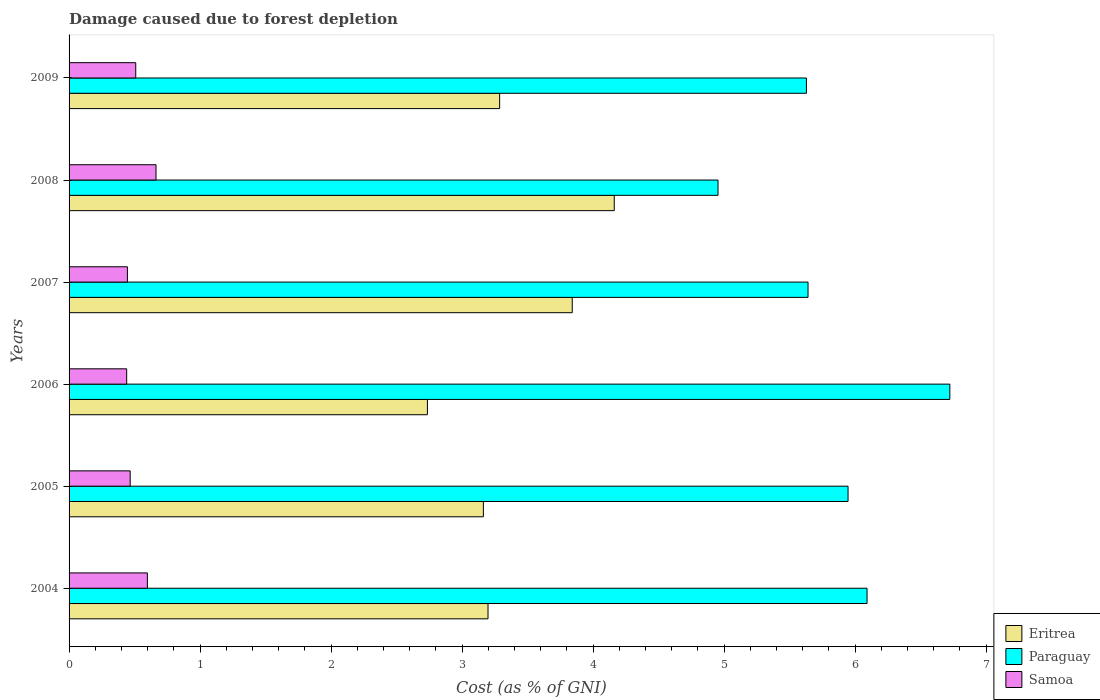How many groups of bars are there?
Provide a short and direct response. 6. Are the number of bars per tick equal to the number of legend labels?
Provide a short and direct response. Yes. What is the label of the 3rd group of bars from the top?
Offer a terse response. 2007. What is the cost of damage caused due to forest depletion in Samoa in 2004?
Provide a succinct answer. 0.6. Across all years, what is the maximum cost of damage caused due to forest depletion in Eritrea?
Make the answer very short. 4.16. Across all years, what is the minimum cost of damage caused due to forest depletion in Paraguay?
Provide a short and direct response. 4.95. What is the total cost of damage caused due to forest depletion in Paraguay in the graph?
Provide a short and direct response. 34.99. What is the difference between the cost of damage caused due to forest depletion in Eritrea in 2006 and that in 2008?
Your answer should be very brief. -1.43. What is the difference between the cost of damage caused due to forest depletion in Samoa in 2006 and the cost of damage caused due to forest depletion in Eritrea in 2007?
Offer a terse response. -3.4. What is the average cost of damage caused due to forest depletion in Paraguay per year?
Give a very brief answer. 5.83. In the year 2009, what is the difference between the cost of damage caused due to forest depletion in Eritrea and cost of damage caused due to forest depletion in Paraguay?
Your answer should be compact. -2.34. What is the ratio of the cost of damage caused due to forest depletion in Samoa in 2004 to that in 2008?
Offer a very short reply. 0.9. Is the difference between the cost of damage caused due to forest depletion in Eritrea in 2005 and 2006 greater than the difference between the cost of damage caused due to forest depletion in Paraguay in 2005 and 2006?
Provide a succinct answer. Yes. What is the difference between the highest and the second highest cost of damage caused due to forest depletion in Samoa?
Offer a terse response. 0.07. What is the difference between the highest and the lowest cost of damage caused due to forest depletion in Eritrea?
Make the answer very short. 1.43. In how many years, is the cost of damage caused due to forest depletion in Samoa greater than the average cost of damage caused due to forest depletion in Samoa taken over all years?
Provide a succinct answer. 2. Is the sum of the cost of damage caused due to forest depletion in Eritrea in 2004 and 2006 greater than the maximum cost of damage caused due to forest depletion in Samoa across all years?
Provide a succinct answer. Yes. What does the 3rd bar from the top in 2004 represents?
Provide a short and direct response. Eritrea. What does the 1st bar from the bottom in 2007 represents?
Your response must be concise. Eritrea. Is it the case that in every year, the sum of the cost of damage caused due to forest depletion in Samoa and cost of damage caused due to forest depletion in Paraguay is greater than the cost of damage caused due to forest depletion in Eritrea?
Make the answer very short. Yes. Are all the bars in the graph horizontal?
Your answer should be compact. Yes. What is the difference between two consecutive major ticks on the X-axis?
Provide a short and direct response. 1. Where does the legend appear in the graph?
Provide a succinct answer. Bottom right. How many legend labels are there?
Keep it short and to the point. 3. How are the legend labels stacked?
Provide a succinct answer. Vertical. What is the title of the graph?
Offer a very short reply. Damage caused due to forest depletion. What is the label or title of the X-axis?
Offer a terse response. Cost (as % of GNI). What is the Cost (as % of GNI) in Eritrea in 2004?
Offer a very short reply. 3.2. What is the Cost (as % of GNI) in Paraguay in 2004?
Provide a succinct answer. 6.09. What is the Cost (as % of GNI) of Samoa in 2004?
Provide a succinct answer. 0.6. What is the Cost (as % of GNI) of Eritrea in 2005?
Your response must be concise. 3.16. What is the Cost (as % of GNI) of Paraguay in 2005?
Provide a short and direct response. 5.95. What is the Cost (as % of GNI) in Samoa in 2005?
Your answer should be compact. 0.47. What is the Cost (as % of GNI) of Eritrea in 2006?
Offer a terse response. 2.74. What is the Cost (as % of GNI) of Paraguay in 2006?
Offer a very short reply. 6.72. What is the Cost (as % of GNI) of Samoa in 2006?
Your answer should be very brief. 0.44. What is the Cost (as % of GNI) in Eritrea in 2007?
Provide a succinct answer. 3.84. What is the Cost (as % of GNI) in Paraguay in 2007?
Offer a terse response. 5.64. What is the Cost (as % of GNI) of Samoa in 2007?
Ensure brevity in your answer.  0.45. What is the Cost (as % of GNI) of Eritrea in 2008?
Provide a succinct answer. 4.16. What is the Cost (as % of GNI) in Paraguay in 2008?
Make the answer very short. 4.95. What is the Cost (as % of GNI) in Samoa in 2008?
Your answer should be very brief. 0.66. What is the Cost (as % of GNI) in Eritrea in 2009?
Your answer should be very brief. 3.29. What is the Cost (as % of GNI) of Paraguay in 2009?
Make the answer very short. 5.63. What is the Cost (as % of GNI) in Samoa in 2009?
Provide a succinct answer. 0.51. Across all years, what is the maximum Cost (as % of GNI) in Eritrea?
Your answer should be very brief. 4.16. Across all years, what is the maximum Cost (as % of GNI) of Paraguay?
Ensure brevity in your answer.  6.72. Across all years, what is the maximum Cost (as % of GNI) in Samoa?
Provide a succinct answer. 0.66. Across all years, what is the minimum Cost (as % of GNI) in Eritrea?
Offer a terse response. 2.74. Across all years, what is the minimum Cost (as % of GNI) in Paraguay?
Provide a succinct answer. 4.95. Across all years, what is the minimum Cost (as % of GNI) of Samoa?
Give a very brief answer. 0.44. What is the total Cost (as % of GNI) in Eritrea in the graph?
Keep it short and to the point. 20.39. What is the total Cost (as % of GNI) in Paraguay in the graph?
Provide a short and direct response. 34.99. What is the total Cost (as % of GNI) of Samoa in the graph?
Provide a succinct answer. 3.12. What is the difference between the Cost (as % of GNI) of Eritrea in 2004 and that in 2005?
Give a very brief answer. 0.04. What is the difference between the Cost (as % of GNI) of Paraguay in 2004 and that in 2005?
Make the answer very short. 0.15. What is the difference between the Cost (as % of GNI) of Samoa in 2004 and that in 2005?
Ensure brevity in your answer.  0.13. What is the difference between the Cost (as % of GNI) in Eritrea in 2004 and that in 2006?
Your answer should be very brief. 0.46. What is the difference between the Cost (as % of GNI) of Paraguay in 2004 and that in 2006?
Your response must be concise. -0.63. What is the difference between the Cost (as % of GNI) in Samoa in 2004 and that in 2006?
Provide a short and direct response. 0.16. What is the difference between the Cost (as % of GNI) in Eritrea in 2004 and that in 2007?
Offer a very short reply. -0.64. What is the difference between the Cost (as % of GNI) of Paraguay in 2004 and that in 2007?
Your answer should be compact. 0.45. What is the difference between the Cost (as % of GNI) in Samoa in 2004 and that in 2007?
Offer a very short reply. 0.15. What is the difference between the Cost (as % of GNI) of Eritrea in 2004 and that in 2008?
Ensure brevity in your answer.  -0.96. What is the difference between the Cost (as % of GNI) in Paraguay in 2004 and that in 2008?
Your response must be concise. 1.14. What is the difference between the Cost (as % of GNI) of Samoa in 2004 and that in 2008?
Keep it short and to the point. -0.07. What is the difference between the Cost (as % of GNI) of Eritrea in 2004 and that in 2009?
Offer a very short reply. -0.09. What is the difference between the Cost (as % of GNI) in Paraguay in 2004 and that in 2009?
Provide a succinct answer. 0.46. What is the difference between the Cost (as % of GNI) of Samoa in 2004 and that in 2009?
Ensure brevity in your answer.  0.09. What is the difference between the Cost (as % of GNI) of Eritrea in 2005 and that in 2006?
Your answer should be compact. 0.43. What is the difference between the Cost (as % of GNI) in Paraguay in 2005 and that in 2006?
Offer a very short reply. -0.78. What is the difference between the Cost (as % of GNI) of Samoa in 2005 and that in 2006?
Your answer should be compact. 0.03. What is the difference between the Cost (as % of GNI) of Eritrea in 2005 and that in 2007?
Your answer should be very brief. -0.68. What is the difference between the Cost (as % of GNI) of Paraguay in 2005 and that in 2007?
Your response must be concise. 0.31. What is the difference between the Cost (as % of GNI) of Samoa in 2005 and that in 2007?
Your response must be concise. 0.02. What is the difference between the Cost (as % of GNI) of Eritrea in 2005 and that in 2008?
Offer a terse response. -1. What is the difference between the Cost (as % of GNI) in Paraguay in 2005 and that in 2008?
Provide a succinct answer. 0.99. What is the difference between the Cost (as % of GNI) in Samoa in 2005 and that in 2008?
Offer a terse response. -0.2. What is the difference between the Cost (as % of GNI) in Eritrea in 2005 and that in 2009?
Ensure brevity in your answer.  -0.12. What is the difference between the Cost (as % of GNI) in Paraguay in 2005 and that in 2009?
Ensure brevity in your answer.  0.32. What is the difference between the Cost (as % of GNI) of Samoa in 2005 and that in 2009?
Your response must be concise. -0.04. What is the difference between the Cost (as % of GNI) of Eritrea in 2006 and that in 2007?
Keep it short and to the point. -1.11. What is the difference between the Cost (as % of GNI) in Paraguay in 2006 and that in 2007?
Your answer should be compact. 1.08. What is the difference between the Cost (as % of GNI) in Samoa in 2006 and that in 2007?
Your response must be concise. -0.01. What is the difference between the Cost (as % of GNI) in Eritrea in 2006 and that in 2008?
Offer a very short reply. -1.43. What is the difference between the Cost (as % of GNI) in Paraguay in 2006 and that in 2008?
Ensure brevity in your answer.  1.77. What is the difference between the Cost (as % of GNI) of Samoa in 2006 and that in 2008?
Your answer should be compact. -0.22. What is the difference between the Cost (as % of GNI) in Eritrea in 2006 and that in 2009?
Provide a short and direct response. -0.55. What is the difference between the Cost (as % of GNI) of Paraguay in 2006 and that in 2009?
Provide a short and direct response. 1.09. What is the difference between the Cost (as % of GNI) in Samoa in 2006 and that in 2009?
Provide a succinct answer. -0.07. What is the difference between the Cost (as % of GNI) of Eritrea in 2007 and that in 2008?
Make the answer very short. -0.32. What is the difference between the Cost (as % of GNI) in Paraguay in 2007 and that in 2008?
Offer a very short reply. 0.69. What is the difference between the Cost (as % of GNI) in Samoa in 2007 and that in 2008?
Ensure brevity in your answer.  -0.22. What is the difference between the Cost (as % of GNI) of Eritrea in 2007 and that in 2009?
Ensure brevity in your answer.  0.55. What is the difference between the Cost (as % of GNI) of Paraguay in 2007 and that in 2009?
Provide a short and direct response. 0.01. What is the difference between the Cost (as % of GNI) in Samoa in 2007 and that in 2009?
Your response must be concise. -0.06. What is the difference between the Cost (as % of GNI) in Eritrea in 2008 and that in 2009?
Keep it short and to the point. 0.87. What is the difference between the Cost (as % of GNI) of Paraguay in 2008 and that in 2009?
Your response must be concise. -0.68. What is the difference between the Cost (as % of GNI) in Samoa in 2008 and that in 2009?
Your response must be concise. 0.15. What is the difference between the Cost (as % of GNI) in Eritrea in 2004 and the Cost (as % of GNI) in Paraguay in 2005?
Make the answer very short. -2.75. What is the difference between the Cost (as % of GNI) of Eritrea in 2004 and the Cost (as % of GNI) of Samoa in 2005?
Provide a short and direct response. 2.73. What is the difference between the Cost (as % of GNI) in Paraguay in 2004 and the Cost (as % of GNI) in Samoa in 2005?
Ensure brevity in your answer.  5.63. What is the difference between the Cost (as % of GNI) in Eritrea in 2004 and the Cost (as % of GNI) in Paraguay in 2006?
Keep it short and to the point. -3.53. What is the difference between the Cost (as % of GNI) in Eritrea in 2004 and the Cost (as % of GNI) in Samoa in 2006?
Your response must be concise. 2.76. What is the difference between the Cost (as % of GNI) of Paraguay in 2004 and the Cost (as % of GNI) of Samoa in 2006?
Give a very brief answer. 5.65. What is the difference between the Cost (as % of GNI) of Eritrea in 2004 and the Cost (as % of GNI) of Paraguay in 2007?
Offer a very short reply. -2.44. What is the difference between the Cost (as % of GNI) in Eritrea in 2004 and the Cost (as % of GNI) in Samoa in 2007?
Provide a succinct answer. 2.75. What is the difference between the Cost (as % of GNI) in Paraguay in 2004 and the Cost (as % of GNI) in Samoa in 2007?
Offer a terse response. 5.65. What is the difference between the Cost (as % of GNI) of Eritrea in 2004 and the Cost (as % of GNI) of Paraguay in 2008?
Keep it short and to the point. -1.76. What is the difference between the Cost (as % of GNI) in Eritrea in 2004 and the Cost (as % of GNI) in Samoa in 2008?
Your answer should be compact. 2.53. What is the difference between the Cost (as % of GNI) in Paraguay in 2004 and the Cost (as % of GNI) in Samoa in 2008?
Your answer should be compact. 5.43. What is the difference between the Cost (as % of GNI) in Eritrea in 2004 and the Cost (as % of GNI) in Paraguay in 2009?
Your response must be concise. -2.43. What is the difference between the Cost (as % of GNI) in Eritrea in 2004 and the Cost (as % of GNI) in Samoa in 2009?
Offer a terse response. 2.69. What is the difference between the Cost (as % of GNI) in Paraguay in 2004 and the Cost (as % of GNI) in Samoa in 2009?
Keep it short and to the point. 5.58. What is the difference between the Cost (as % of GNI) in Eritrea in 2005 and the Cost (as % of GNI) in Paraguay in 2006?
Your answer should be very brief. -3.56. What is the difference between the Cost (as % of GNI) of Eritrea in 2005 and the Cost (as % of GNI) of Samoa in 2006?
Your response must be concise. 2.72. What is the difference between the Cost (as % of GNI) in Paraguay in 2005 and the Cost (as % of GNI) in Samoa in 2006?
Keep it short and to the point. 5.51. What is the difference between the Cost (as % of GNI) of Eritrea in 2005 and the Cost (as % of GNI) of Paraguay in 2007?
Offer a terse response. -2.48. What is the difference between the Cost (as % of GNI) in Eritrea in 2005 and the Cost (as % of GNI) in Samoa in 2007?
Provide a short and direct response. 2.72. What is the difference between the Cost (as % of GNI) in Paraguay in 2005 and the Cost (as % of GNI) in Samoa in 2007?
Your answer should be compact. 5.5. What is the difference between the Cost (as % of GNI) in Eritrea in 2005 and the Cost (as % of GNI) in Paraguay in 2008?
Your answer should be very brief. -1.79. What is the difference between the Cost (as % of GNI) in Eritrea in 2005 and the Cost (as % of GNI) in Samoa in 2008?
Your answer should be very brief. 2.5. What is the difference between the Cost (as % of GNI) in Paraguay in 2005 and the Cost (as % of GNI) in Samoa in 2008?
Keep it short and to the point. 5.28. What is the difference between the Cost (as % of GNI) in Eritrea in 2005 and the Cost (as % of GNI) in Paraguay in 2009?
Provide a succinct answer. -2.47. What is the difference between the Cost (as % of GNI) of Eritrea in 2005 and the Cost (as % of GNI) of Samoa in 2009?
Give a very brief answer. 2.65. What is the difference between the Cost (as % of GNI) of Paraguay in 2005 and the Cost (as % of GNI) of Samoa in 2009?
Your response must be concise. 5.44. What is the difference between the Cost (as % of GNI) in Eritrea in 2006 and the Cost (as % of GNI) in Paraguay in 2007?
Offer a very short reply. -2.91. What is the difference between the Cost (as % of GNI) of Eritrea in 2006 and the Cost (as % of GNI) of Samoa in 2007?
Offer a very short reply. 2.29. What is the difference between the Cost (as % of GNI) of Paraguay in 2006 and the Cost (as % of GNI) of Samoa in 2007?
Offer a very short reply. 6.28. What is the difference between the Cost (as % of GNI) of Eritrea in 2006 and the Cost (as % of GNI) of Paraguay in 2008?
Provide a short and direct response. -2.22. What is the difference between the Cost (as % of GNI) in Eritrea in 2006 and the Cost (as % of GNI) in Samoa in 2008?
Your answer should be compact. 2.07. What is the difference between the Cost (as % of GNI) of Paraguay in 2006 and the Cost (as % of GNI) of Samoa in 2008?
Your answer should be very brief. 6.06. What is the difference between the Cost (as % of GNI) of Eritrea in 2006 and the Cost (as % of GNI) of Paraguay in 2009?
Give a very brief answer. -2.89. What is the difference between the Cost (as % of GNI) in Eritrea in 2006 and the Cost (as % of GNI) in Samoa in 2009?
Keep it short and to the point. 2.23. What is the difference between the Cost (as % of GNI) of Paraguay in 2006 and the Cost (as % of GNI) of Samoa in 2009?
Make the answer very short. 6.21. What is the difference between the Cost (as % of GNI) of Eritrea in 2007 and the Cost (as % of GNI) of Paraguay in 2008?
Make the answer very short. -1.11. What is the difference between the Cost (as % of GNI) of Eritrea in 2007 and the Cost (as % of GNI) of Samoa in 2008?
Keep it short and to the point. 3.18. What is the difference between the Cost (as % of GNI) of Paraguay in 2007 and the Cost (as % of GNI) of Samoa in 2008?
Provide a short and direct response. 4.98. What is the difference between the Cost (as % of GNI) of Eritrea in 2007 and the Cost (as % of GNI) of Paraguay in 2009?
Offer a terse response. -1.79. What is the difference between the Cost (as % of GNI) of Eritrea in 2007 and the Cost (as % of GNI) of Samoa in 2009?
Your answer should be compact. 3.33. What is the difference between the Cost (as % of GNI) of Paraguay in 2007 and the Cost (as % of GNI) of Samoa in 2009?
Make the answer very short. 5.13. What is the difference between the Cost (as % of GNI) in Eritrea in 2008 and the Cost (as % of GNI) in Paraguay in 2009?
Offer a very short reply. -1.47. What is the difference between the Cost (as % of GNI) of Eritrea in 2008 and the Cost (as % of GNI) of Samoa in 2009?
Provide a short and direct response. 3.65. What is the difference between the Cost (as % of GNI) of Paraguay in 2008 and the Cost (as % of GNI) of Samoa in 2009?
Offer a terse response. 4.45. What is the average Cost (as % of GNI) of Eritrea per year?
Keep it short and to the point. 3.4. What is the average Cost (as % of GNI) in Paraguay per year?
Give a very brief answer. 5.83. What is the average Cost (as % of GNI) of Samoa per year?
Ensure brevity in your answer.  0.52. In the year 2004, what is the difference between the Cost (as % of GNI) of Eritrea and Cost (as % of GNI) of Paraguay?
Offer a terse response. -2.89. In the year 2004, what is the difference between the Cost (as % of GNI) in Eritrea and Cost (as % of GNI) in Samoa?
Ensure brevity in your answer.  2.6. In the year 2004, what is the difference between the Cost (as % of GNI) in Paraguay and Cost (as % of GNI) in Samoa?
Ensure brevity in your answer.  5.49. In the year 2005, what is the difference between the Cost (as % of GNI) of Eritrea and Cost (as % of GNI) of Paraguay?
Your answer should be very brief. -2.78. In the year 2005, what is the difference between the Cost (as % of GNI) of Eritrea and Cost (as % of GNI) of Samoa?
Your answer should be very brief. 2.7. In the year 2005, what is the difference between the Cost (as % of GNI) in Paraguay and Cost (as % of GNI) in Samoa?
Ensure brevity in your answer.  5.48. In the year 2006, what is the difference between the Cost (as % of GNI) of Eritrea and Cost (as % of GNI) of Paraguay?
Your response must be concise. -3.99. In the year 2006, what is the difference between the Cost (as % of GNI) in Eritrea and Cost (as % of GNI) in Samoa?
Make the answer very short. 2.3. In the year 2006, what is the difference between the Cost (as % of GNI) in Paraguay and Cost (as % of GNI) in Samoa?
Offer a very short reply. 6.28. In the year 2007, what is the difference between the Cost (as % of GNI) in Eritrea and Cost (as % of GNI) in Paraguay?
Provide a short and direct response. -1.8. In the year 2007, what is the difference between the Cost (as % of GNI) in Eritrea and Cost (as % of GNI) in Samoa?
Your answer should be compact. 3.4. In the year 2007, what is the difference between the Cost (as % of GNI) of Paraguay and Cost (as % of GNI) of Samoa?
Give a very brief answer. 5.2. In the year 2008, what is the difference between the Cost (as % of GNI) of Eritrea and Cost (as % of GNI) of Paraguay?
Your answer should be very brief. -0.79. In the year 2008, what is the difference between the Cost (as % of GNI) in Eritrea and Cost (as % of GNI) in Samoa?
Provide a short and direct response. 3.5. In the year 2008, what is the difference between the Cost (as % of GNI) of Paraguay and Cost (as % of GNI) of Samoa?
Your response must be concise. 4.29. In the year 2009, what is the difference between the Cost (as % of GNI) of Eritrea and Cost (as % of GNI) of Paraguay?
Make the answer very short. -2.34. In the year 2009, what is the difference between the Cost (as % of GNI) in Eritrea and Cost (as % of GNI) in Samoa?
Offer a terse response. 2.78. In the year 2009, what is the difference between the Cost (as % of GNI) in Paraguay and Cost (as % of GNI) in Samoa?
Make the answer very short. 5.12. What is the ratio of the Cost (as % of GNI) in Eritrea in 2004 to that in 2005?
Your response must be concise. 1.01. What is the ratio of the Cost (as % of GNI) of Paraguay in 2004 to that in 2005?
Offer a terse response. 1.02. What is the ratio of the Cost (as % of GNI) in Samoa in 2004 to that in 2005?
Offer a very short reply. 1.28. What is the ratio of the Cost (as % of GNI) in Eritrea in 2004 to that in 2006?
Offer a very short reply. 1.17. What is the ratio of the Cost (as % of GNI) of Paraguay in 2004 to that in 2006?
Provide a succinct answer. 0.91. What is the ratio of the Cost (as % of GNI) of Samoa in 2004 to that in 2006?
Your answer should be compact. 1.36. What is the ratio of the Cost (as % of GNI) in Eritrea in 2004 to that in 2007?
Offer a very short reply. 0.83. What is the ratio of the Cost (as % of GNI) in Paraguay in 2004 to that in 2007?
Keep it short and to the point. 1.08. What is the ratio of the Cost (as % of GNI) in Samoa in 2004 to that in 2007?
Offer a terse response. 1.34. What is the ratio of the Cost (as % of GNI) of Eritrea in 2004 to that in 2008?
Your response must be concise. 0.77. What is the ratio of the Cost (as % of GNI) of Paraguay in 2004 to that in 2008?
Make the answer very short. 1.23. What is the ratio of the Cost (as % of GNI) in Samoa in 2004 to that in 2008?
Your response must be concise. 0.9. What is the ratio of the Cost (as % of GNI) in Eritrea in 2004 to that in 2009?
Your answer should be very brief. 0.97. What is the ratio of the Cost (as % of GNI) in Paraguay in 2004 to that in 2009?
Provide a succinct answer. 1.08. What is the ratio of the Cost (as % of GNI) of Samoa in 2004 to that in 2009?
Keep it short and to the point. 1.17. What is the ratio of the Cost (as % of GNI) in Eritrea in 2005 to that in 2006?
Give a very brief answer. 1.16. What is the ratio of the Cost (as % of GNI) in Paraguay in 2005 to that in 2006?
Your answer should be very brief. 0.88. What is the ratio of the Cost (as % of GNI) of Samoa in 2005 to that in 2006?
Make the answer very short. 1.06. What is the ratio of the Cost (as % of GNI) in Eritrea in 2005 to that in 2007?
Make the answer very short. 0.82. What is the ratio of the Cost (as % of GNI) in Paraguay in 2005 to that in 2007?
Make the answer very short. 1.05. What is the ratio of the Cost (as % of GNI) in Samoa in 2005 to that in 2007?
Your answer should be very brief. 1.05. What is the ratio of the Cost (as % of GNI) of Eritrea in 2005 to that in 2008?
Keep it short and to the point. 0.76. What is the ratio of the Cost (as % of GNI) in Paraguay in 2005 to that in 2008?
Offer a terse response. 1.2. What is the ratio of the Cost (as % of GNI) in Samoa in 2005 to that in 2008?
Offer a terse response. 0.7. What is the ratio of the Cost (as % of GNI) of Eritrea in 2005 to that in 2009?
Provide a succinct answer. 0.96. What is the ratio of the Cost (as % of GNI) of Paraguay in 2005 to that in 2009?
Your answer should be compact. 1.06. What is the ratio of the Cost (as % of GNI) in Eritrea in 2006 to that in 2007?
Keep it short and to the point. 0.71. What is the ratio of the Cost (as % of GNI) of Paraguay in 2006 to that in 2007?
Offer a very short reply. 1.19. What is the ratio of the Cost (as % of GNI) in Samoa in 2006 to that in 2007?
Your answer should be very brief. 0.99. What is the ratio of the Cost (as % of GNI) of Eritrea in 2006 to that in 2008?
Your answer should be very brief. 0.66. What is the ratio of the Cost (as % of GNI) of Paraguay in 2006 to that in 2008?
Offer a terse response. 1.36. What is the ratio of the Cost (as % of GNI) of Samoa in 2006 to that in 2008?
Make the answer very short. 0.66. What is the ratio of the Cost (as % of GNI) in Eritrea in 2006 to that in 2009?
Offer a very short reply. 0.83. What is the ratio of the Cost (as % of GNI) in Paraguay in 2006 to that in 2009?
Make the answer very short. 1.19. What is the ratio of the Cost (as % of GNI) in Samoa in 2006 to that in 2009?
Offer a terse response. 0.86. What is the ratio of the Cost (as % of GNI) of Eritrea in 2007 to that in 2008?
Offer a very short reply. 0.92. What is the ratio of the Cost (as % of GNI) of Paraguay in 2007 to that in 2008?
Make the answer very short. 1.14. What is the ratio of the Cost (as % of GNI) in Samoa in 2007 to that in 2008?
Provide a short and direct response. 0.67. What is the ratio of the Cost (as % of GNI) of Eritrea in 2007 to that in 2009?
Keep it short and to the point. 1.17. What is the ratio of the Cost (as % of GNI) of Paraguay in 2007 to that in 2009?
Provide a succinct answer. 1. What is the ratio of the Cost (as % of GNI) of Samoa in 2007 to that in 2009?
Offer a terse response. 0.87. What is the ratio of the Cost (as % of GNI) in Eritrea in 2008 to that in 2009?
Your answer should be very brief. 1.27. What is the ratio of the Cost (as % of GNI) of Paraguay in 2008 to that in 2009?
Keep it short and to the point. 0.88. What is the ratio of the Cost (as % of GNI) in Samoa in 2008 to that in 2009?
Provide a short and direct response. 1.3. What is the difference between the highest and the second highest Cost (as % of GNI) in Eritrea?
Ensure brevity in your answer.  0.32. What is the difference between the highest and the second highest Cost (as % of GNI) of Paraguay?
Offer a very short reply. 0.63. What is the difference between the highest and the second highest Cost (as % of GNI) of Samoa?
Your answer should be compact. 0.07. What is the difference between the highest and the lowest Cost (as % of GNI) in Eritrea?
Offer a terse response. 1.43. What is the difference between the highest and the lowest Cost (as % of GNI) of Paraguay?
Ensure brevity in your answer.  1.77. What is the difference between the highest and the lowest Cost (as % of GNI) in Samoa?
Provide a succinct answer. 0.22. 